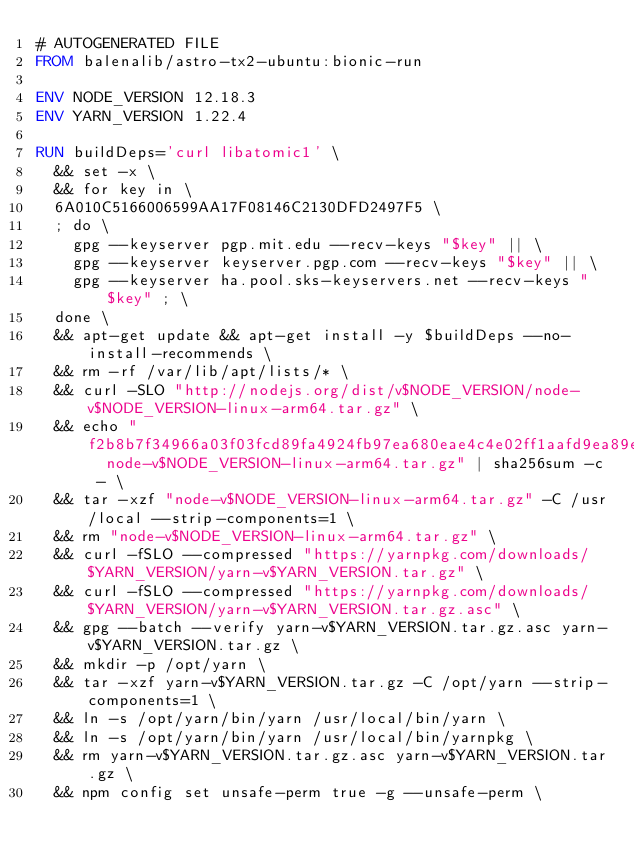Convert code to text. <code><loc_0><loc_0><loc_500><loc_500><_Dockerfile_># AUTOGENERATED FILE
FROM balenalib/astro-tx2-ubuntu:bionic-run

ENV NODE_VERSION 12.18.3
ENV YARN_VERSION 1.22.4

RUN buildDeps='curl libatomic1' \
	&& set -x \
	&& for key in \
	6A010C5166006599AA17F08146C2130DFD2497F5 \
	; do \
		gpg --keyserver pgp.mit.edu --recv-keys "$key" || \
		gpg --keyserver keyserver.pgp.com --recv-keys "$key" || \
		gpg --keyserver ha.pool.sks-keyservers.net --recv-keys "$key" ; \
	done \
	&& apt-get update && apt-get install -y $buildDeps --no-install-recommends \
	&& rm -rf /var/lib/apt/lists/* \
	&& curl -SLO "http://nodejs.org/dist/v$NODE_VERSION/node-v$NODE_VERSION-linux-arm64.tar.gz" \
	&& echo "f2b8b7f34966a03f03fcd89fa4924fb97ea680eae4c4e02ff1aafd9ea89ecad8  node-v$NODE_VERSION-linux-arm64.tar.gz" | sha256sum -c - \
	&& tar -xzf "node-v$NODE_VERSION-linux-arm64.tar.gz" -C /usr/local --strip-components=1 \
	&& rm "node-v$NODE_VERSION-linux-arm64.tar.gz" \
	&& curl -fSLO --compressed "https://yarnpkg.com/downloads/$YARN_VERSION/yarn-v$YARN_VERSION.tar.gz" \
	&& curl -fSLO --compressed "https://yarnpkg.com/downloads/$YARN_VERSION/yarn-v$YARN_VERSION.tar.gz.asc" \
	&& gpg --batch --verify yarn-v$YARN_VERSION.tar.gz.asc yarn-v$YARN_VERSION.tar.gz \
	&& mkdir -p /opt/yarn \
	&& tar -xzf yarn-v$YARN_VERSION.tar.gz -C /opt/yarn --strip-components=1 \
	&& ln -s /opt/yarn/bin/yarn /usr/local/bin/yarn \
	&& ln -s /opt/yarn/bin/yarn /usr/local/bin/yarnpkg \
	&& rm yarn-v$YARN_VERSION.tar.gz.asc yarn-v$YARN_VERSION.tar.gz \
	&& npm config set unsafe-perm true -g --unsafe-perm \</code> 